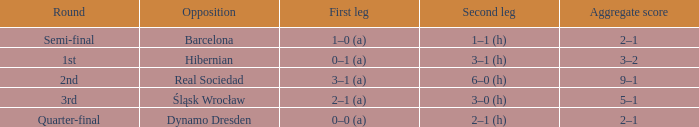What was the first leg of the semi-final? 1–0 (a). 